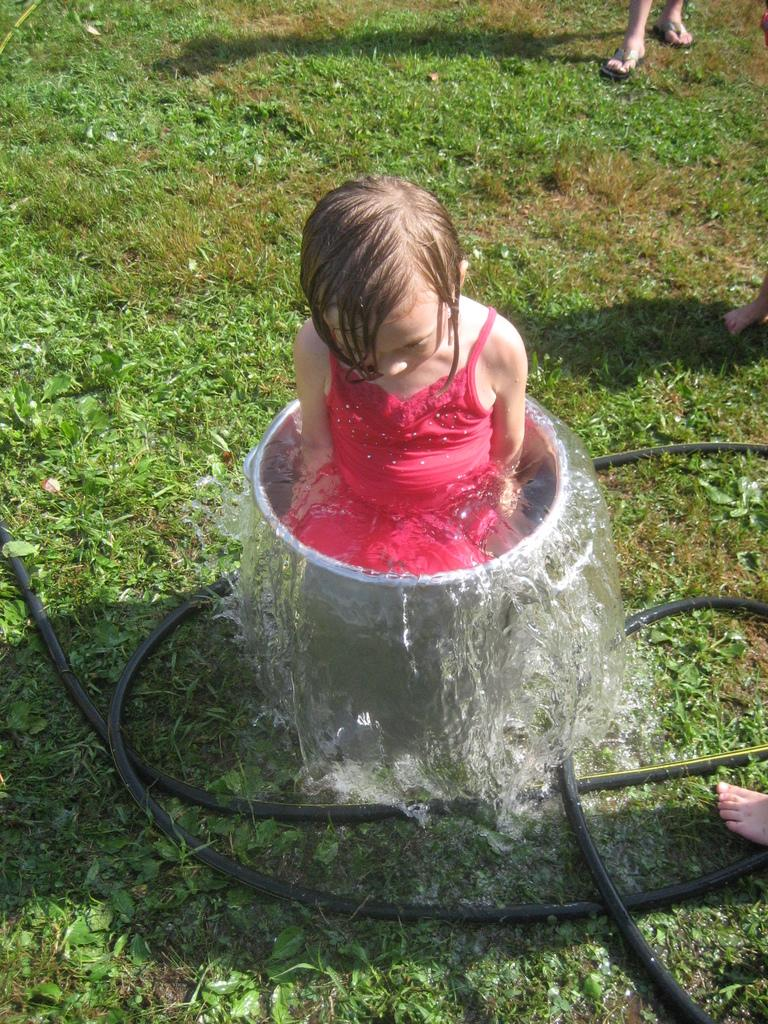What is the person in the image doing? The person is in a bucket in the image. What is the person in the bucket wearing? The person in the bucket is wearing a red dress. Can you describe the background of the image? There is another person standing in the background of the image, and the grass is green. What type of jail can be seen in the background of the image? There is no jail present in the image; it features a person in a bucket and another person standing in the background with green grass. 